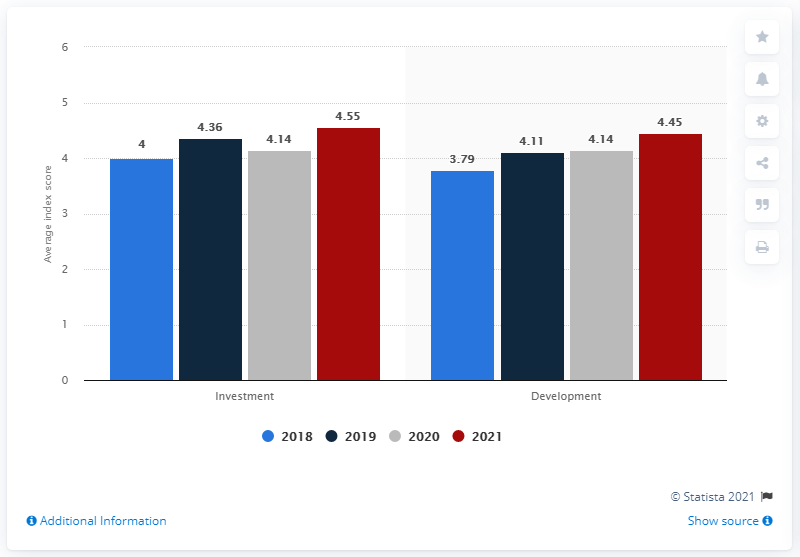Mention a couple of crucial points in this snapshot. The red bars represent the year 2021. The sum of the largest investment and the smallest development is 8.34. 